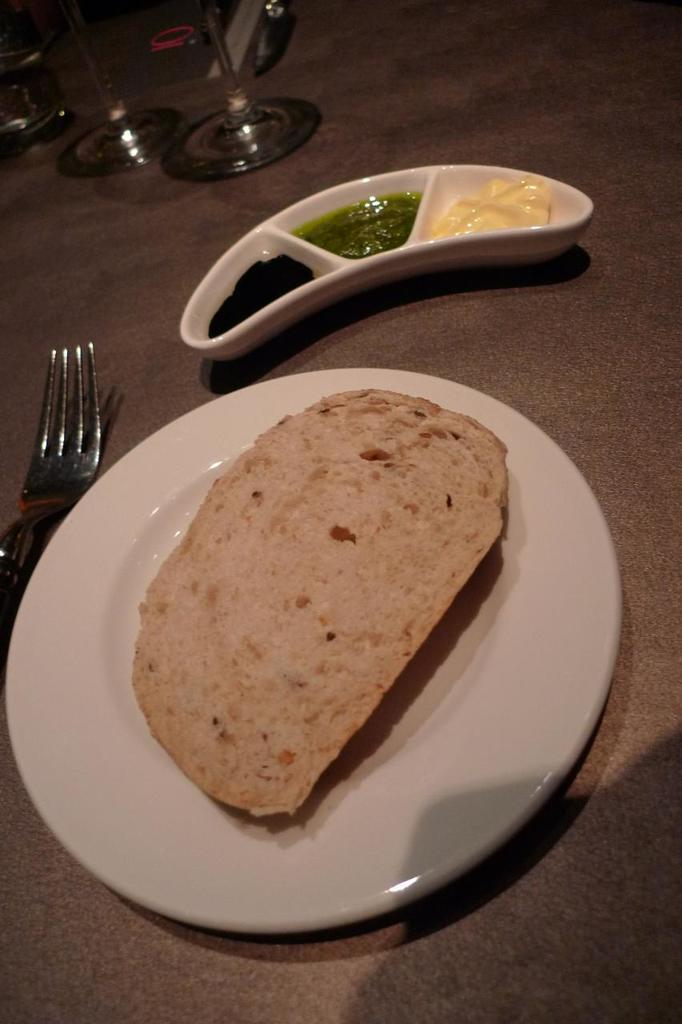What objects can be seen on the table in the image? There are plates, glasses, and a fork on the table in the image. What is on the plates? There is food on the plates. What accompanies the food on the plates? There is a bread on one of the plates. What can be used for condiments or dipping in the image? There are sauces in the image. What type of game is being played on the table in the image? There is no game being played on the table in the image. Can you describe the elbow of the person sitting at the table? There is no person visible in the image, so it is not possible to describe their elbow. 